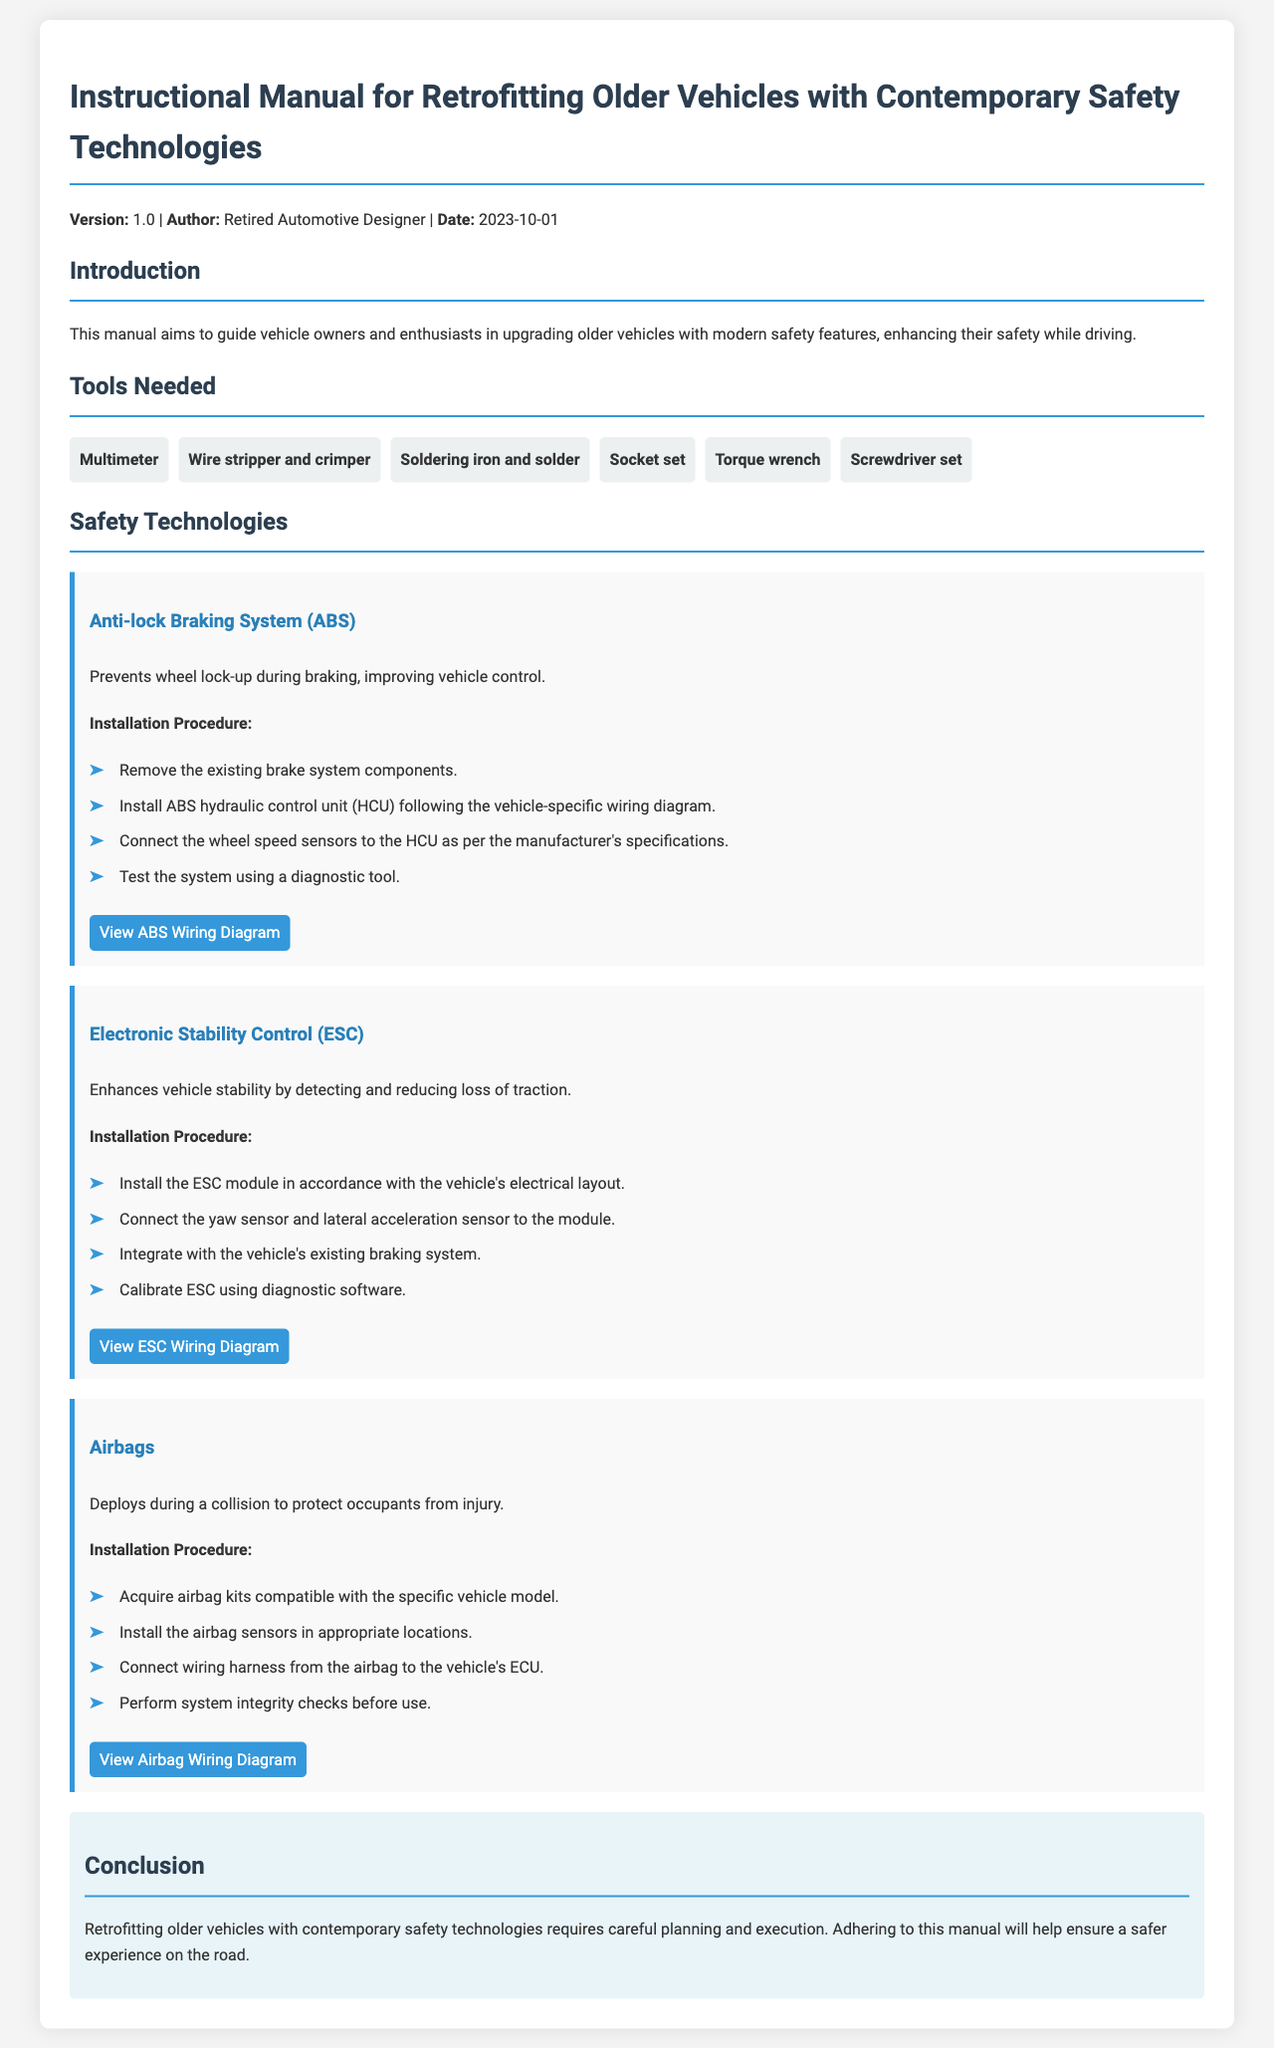What is the version of the manual? The version of the manual is specified in the document's header section.
Answer: 1.0 Who is the author of the manual? The author of the manual is mentioned alongside the version and date.
Answer: Retired Automotive Designer What is the date of publication? The date is provided in the header section of the document.
Answer: 2023-10-01 What type of system does the Anti-lock Braking System prevent? The document states the function of the ABS.
Answer: Wheel lock-up What is the first installation step for the Electronic Stability Control? The installation steps for ESC are outlined in the relevant section.
Answer: Install the ESC module How many tools are listed as needed for the retrofitting process? The total number of tools is provided in the Tools Needed section of the document.
Answer: 6 What safety feature deploys during a collision? The document describes various safety technologies, including airbags.
Answer: Airbags What does the section on Safety Technologies primarily focus on? The primary focus of this section is on modern safety features compatible with retrofitting.
Answer: Safety features What is the conclusion of the manual about retrofitting older vehicles? The conclusion summarizes the importance of the guidelines for ensuring safety.
Answer: A safer experience on the road What type of wiring diagram can be viewed for the Airbags? The document provides access to wiring diagrams for specific technologies.
Answer: Airbag Wiring Diagram 